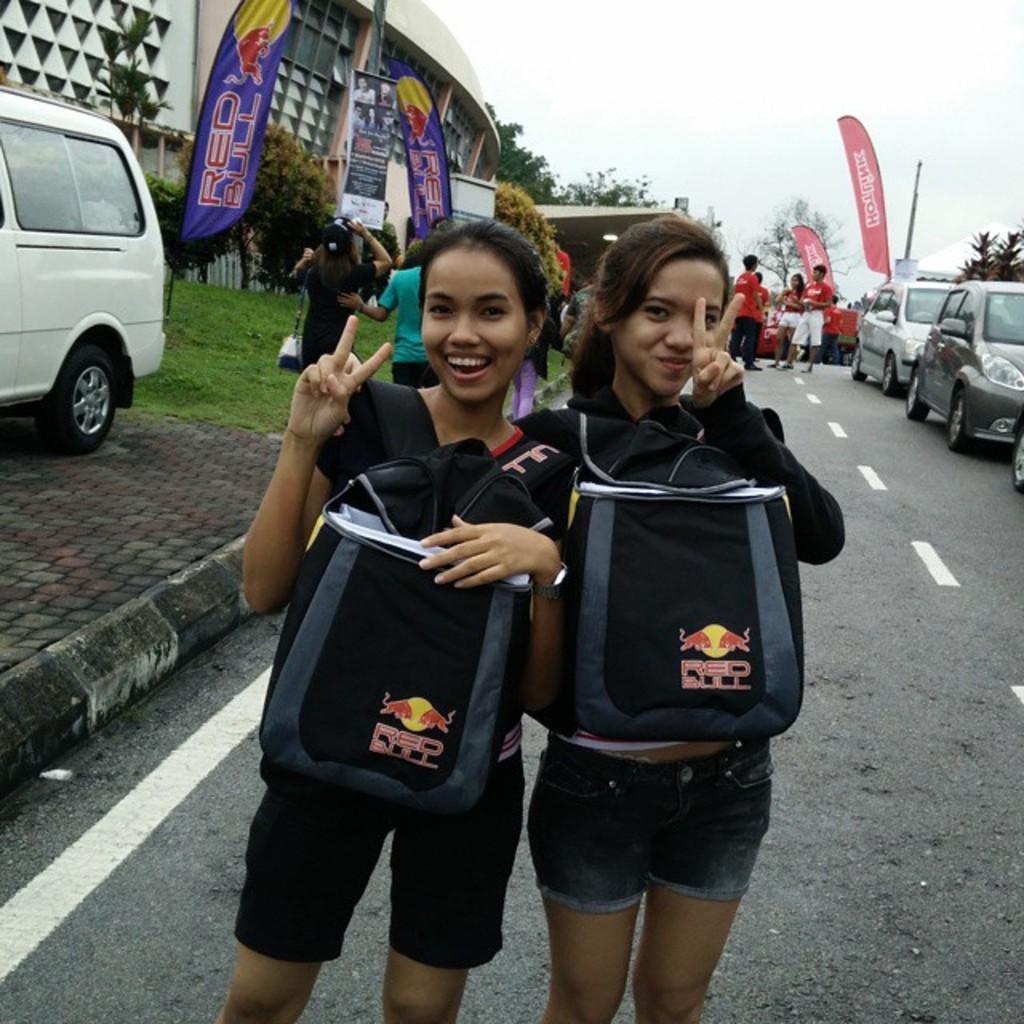Please provide a concise description of this image. There are two women standing and smiling and carrying bags. We can see grass, vehicles, road and people. In the background we can see building, banners, pole, trees and sky. 